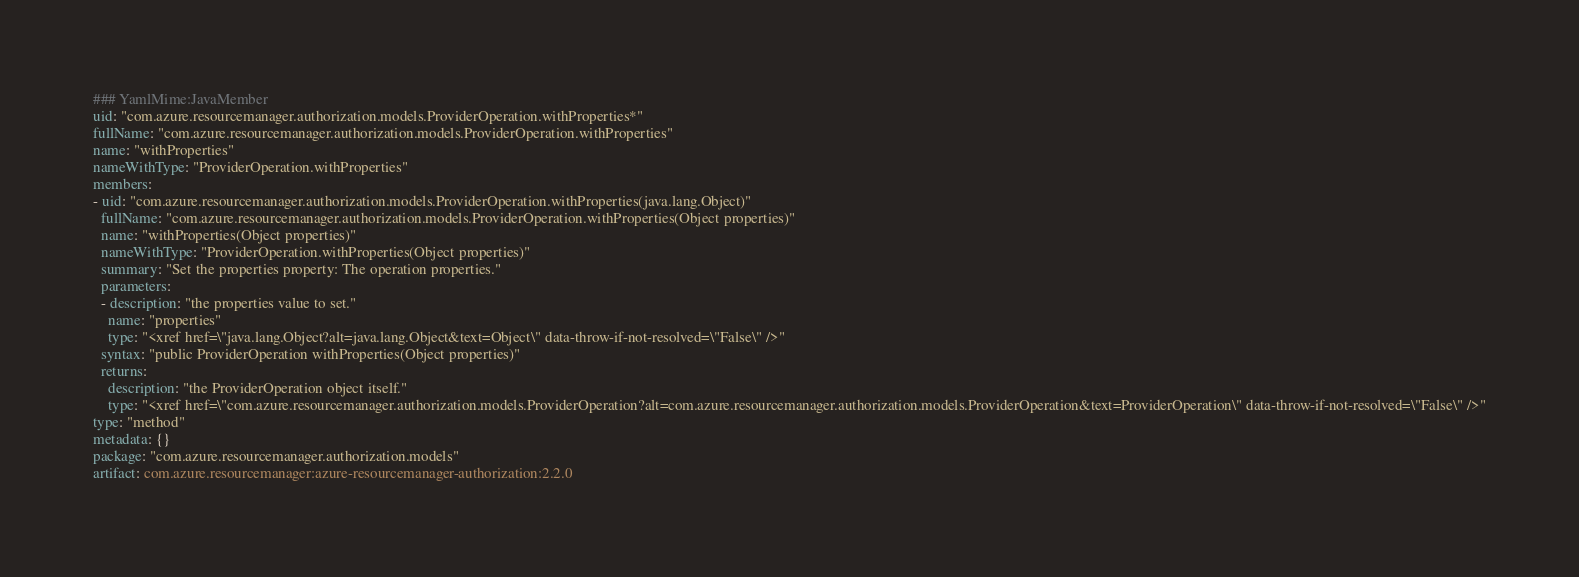Convert code to text. <code><loc_0><loc_0><loc_500><loc_500><_YAML_>### YamlMime:JavaMember
uid: "com.azure.resourcemanager.authorization.models.ProviderOperation.withProperties*"
fullName: "com.azure.resourcemanager.authorization.models.ProviderOperation.withProperties"
name: "withProperties"
nameWithType: "ProviderOperation.withProperties"
members:
- uid: "com.azure.resourcemanager.authorization.models.ProviderOperation.withProperties(java.lang.Object)"
  fullName: "com.azure.resourcemanager.authorization.models.ProviderOperation.withProperties(Object properties)"
  name: "withProperties(Object properties)"
  nameWithType: "ProviderOperation.withProperties(Object properties)"
  summary: "Set the properties property: The operation properties."
  parameters:
  - description: "the properties value to set."
    name: "properties"
    type: "<xref href=\"java.lang.Object?alt=java.lang.Object&text=Object\" data-throw-if-not-resolved=\"False\" />"
  syntax: "public ProviderOperation withProperties(Object properties)"
  returns:
    description: "the ProviderOperation object itself."
    type: "<xref href=\"com.azure.resourcemanager.authorization.models.ProviderOperation?alt=com.azure.resourcemanager.authorization.models.ProviderOperation&text=ProviderOperation\" data-throw-if-not-resolved=\"False\" />"
type: "method"
metadata: {}
package: "com.azure.resourcemanager.authorization.models"
artifact: com.azure.resourcemanager:azure-resourcemanager-authorization:2.2.0
</code> 